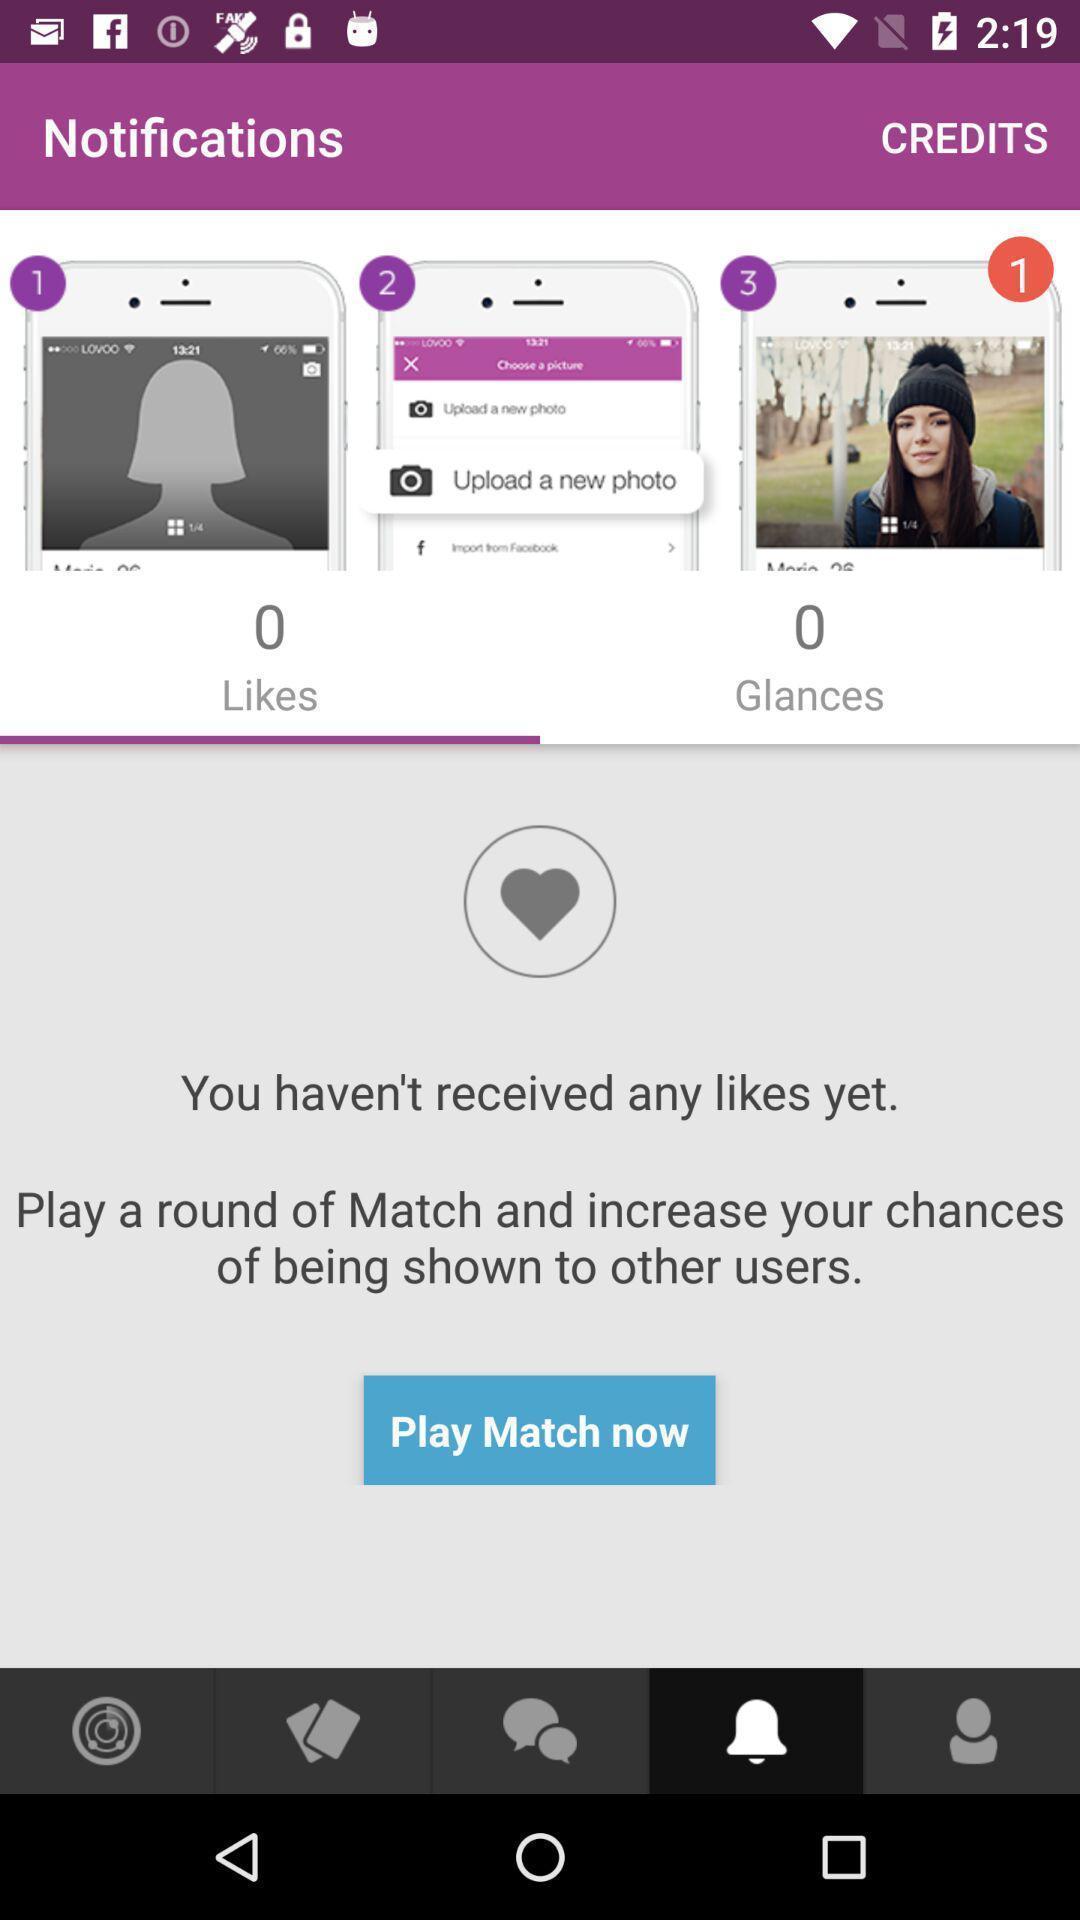Please provide a description for this image. Page for the dating application. 